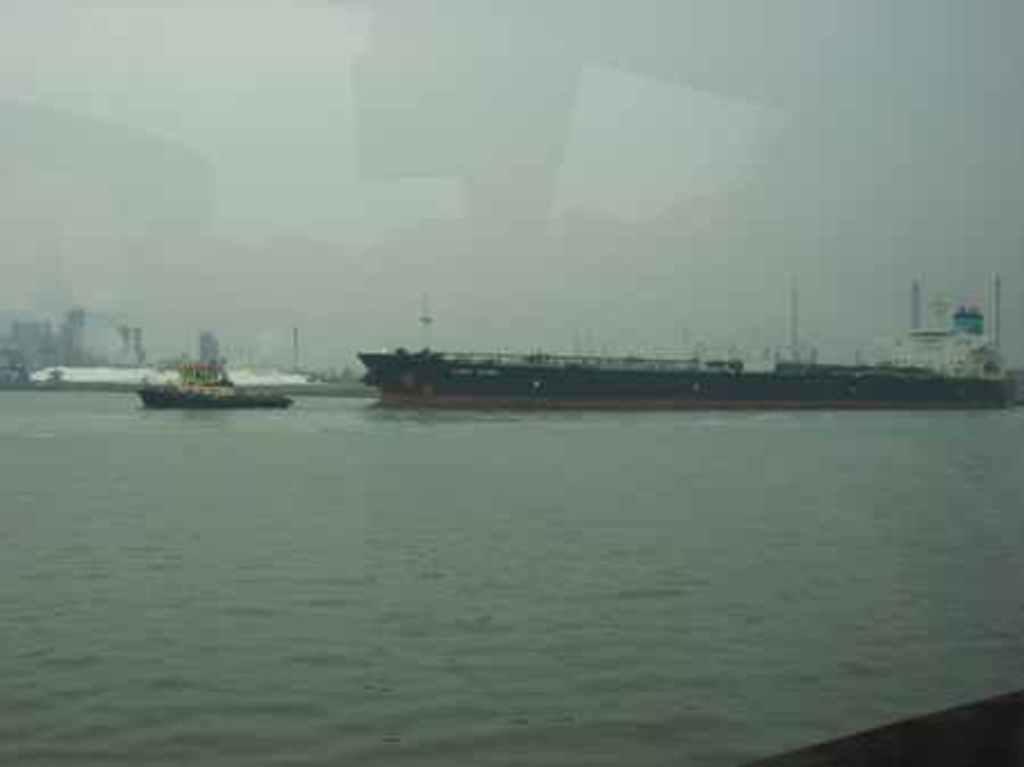Please provide a concise description of this image. In this image we can see some ships in a large water body. On the backside we can see some buildings, poles and the sky. 